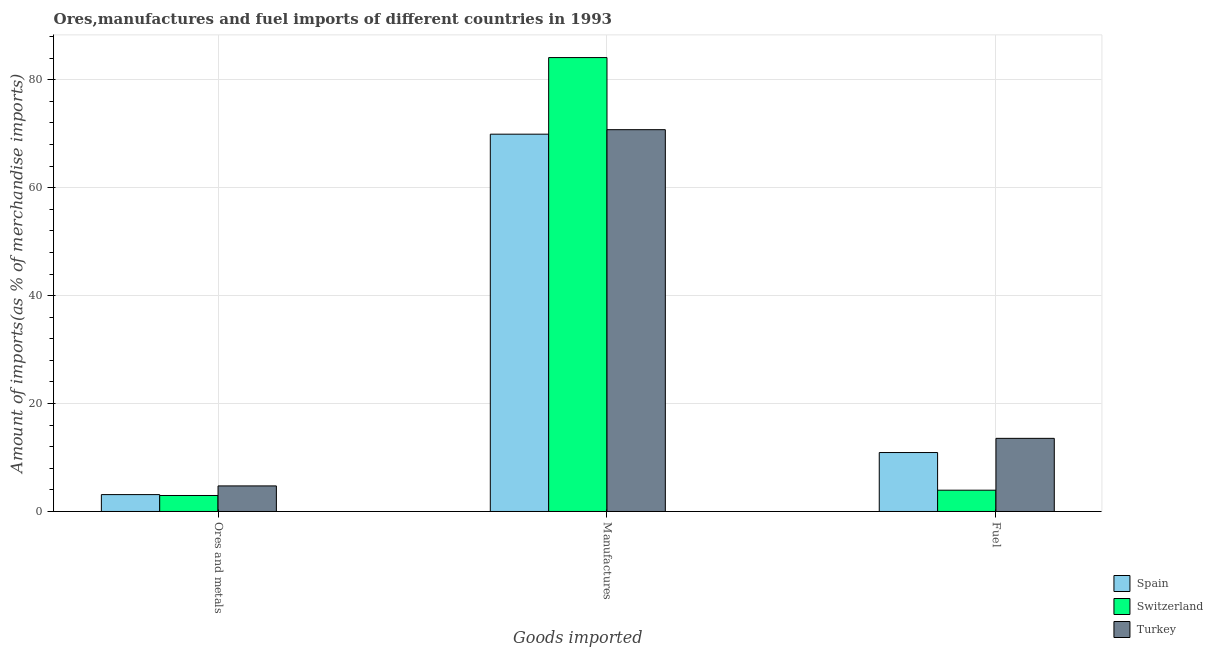Are the number of bars per tick equal to the number of legend labels?
Your answer should be very brief. Yes. Are the number of bars on each tick of the X-axis equal?
Your answer should be very brief. Yes. How many bars are there on the 1st tick from the left?
Offer a terse response. 3. What is the label of the 3rd group of bars from the left?
Your answer should be very brief. Fuel. What is the percentage of fuel imports in Switzerland?
Offer a terse response. 3.95. Across all countries, what is the maximum percentage of manufactures imports?
Provide a succinct answer. 84.12. Across all countries, what is the minimum percentage of ores and metals imports?
Your answer should be very brief. 2.96. In which country was the percentage of manufactures imports maximum?
Your answer should be compact. Switzerland. In which country was the percentage of ores and metals imports minimum?
Your answer should be compact. Switzerland. What is the total percentage of fuel imports in the graph?
Your response must be concise. 28.42. What is the difference between the percentage of ores and metals imports in Turkey and that in Switzerland?
Your answer should be very brief. 1.78. What is the difference between the percentage of manufactures imports in Switzerland and the percentage of fuel imports in Turkey?
Make the answer very short. 70.57. What is the average percentage of fuel imports per country?
Make the answer very short. 9.47. What is the difference between the percentage of manufactures imports and percentage of ores and metals imports in Spain?
Your response must be concise. 66.79. In how many countries, is the percentage of ores and metals imports greater than 20 %?
Keep it short and to the point. 0. What is the ratio of the percentage of fuel imports in Turkey to that in Switzerland?
Offer a terse response. 3.43. Is the percentage of fuel imports in Turkey less than that in Switzerland?
Your answer should be compact. No. What is the difference between the highest and the second highest percentage of fuel imports?
Keep it short and to the point. 2.63. What is the difference between the highest and the lowest percentage of manufactures imports?
Your answer should be very brief. 14.2. In how many countries, is the percentage of ores and metals imports greater than the average percentage of ores and metals imports taken over all countries?
Offer a very short reply. 1. Is the sum of the percentage of fuel imports in Spain and Switzerland greater than the maximum percentage of manufactures imports across all countries?
Offer a very short reply. No. What does the 2nd bar from the left in Manufactures represents?
Provide a short and direct response. Switzerland. What does the 1st bar from the right in Ores and metals represents?
Your answer should be very brief. Turkey. How many bars are there?
Offer a terse response. 9. Are all the bars in the graph horizontal?
Provide a short and direct response. No. How many countries are there in the graph?
Your answer should be compact. 3. What is the difference between two consecutive major ticks on the Y-axis?
Provide a succinct answer. 20. Does the graph contain any zero values?
Ensure brevity in your answer.  No. How many legend labels are there?
Ensure brevity in your answer.  3. What is the title of the graph?
Provide a succinct answer. Ores,manufactures and fuel imports of different countries in 1993. What is the label or title of the X-axis?
Provide a short and direct response. Goods imported. What is the label or title of the Y-axis?
Make the answer very short. Amount of imports(as % of merchandise imports). What is the Amount of imports(as % of merchandise imports) in Spain in Ores and metals?
Provide a short and direct response. 3.13. What is the Amount of imports(as % of merchandise imports) in Switzerland in Ores and metals?
Your answer should be very brief. 2.96. What is the Amount of imports(as % of merchandise imports) in Turkey in Ores and metals?
Ensure brevity in your answer.  4.74. What is the Amount of imports(as % of merchandise imports) of Spain in Manufactures?
Keep it short and to the point. 69.92. What is the Amount of imports(as % of merchandise imports) in Switzerland in Manufactures?
Your response must be concise. 84.12. What is the Amount of imports(as % of merchandise imports) of Turkey in Manufactures?
Your answer should be very brief. 70.76. What is the Amount of imports(as % of merchandise imports) in Spain in Fuel?
Give a very brief answer. 10.92. What is the Amount of imports(as % of merchandise imports) of Switzerland in Fuel?
Make the answer very short. 3.95. What is the Amount of imports(as % of merchandise imports) of Turkey in Fuel?
Ensure brevity in your answer.  13.55. Across all Goods imported, what is the maximum Amount of imports(as % of merchandise imports) in Spain?
Make the answer very short. 69.92. Across all Goods imported, what is the maximum Amount of imports(as % of merchandise imports) of Switzerland?
Make the answer very short. 84.12. Across all Goods imported, what is the maximum Amount of imports(as % of merchandise imports) of Turkey?
Make the answer very short. 70.76. Across all Goods imported, what is the minimum Amount of imports(as % of merchandise imports) of Spain?
Offer a very short reply. 3.13. Across all Goods imported, what is the minimum Amount of imports(as % of merchandise imports) in Switzerland?
Ensure brevity in your answer.  2.96. Across all Goods imported, what is the minimum Amount of imports(as % of merchandise imports) in Turkey?
Give a very brief answer. 4.74. What is the total Amount of imports(as % of merchandise imports) of Spain in the graph?
Your answer should be very brief. 83.98. What is the total Amount of imports(as % of merchandise imports) of Switzerland in the graph?
Make the answer very short. 91.03. What is the total Amount of imports(as % of merchandise imports) of Turkey in the graph?
Ensure brevity in your answer.  89.05. What is the difference between the Amount of imports(as % of merchandise imports) of Spain in Ores and metals and that in Manufactures?
Offer a terse response. -66.79. What is the difference between the Amount of imports(as % of merchandise imports) in Switzerland in Ores and metals and that in Manufactures?
Ensure brevity in your answer.  -81.16. What is the difference between the Amount of imports(as % of merchandise imports) in Turkey in Ores and metals and that in Manufactures?
Your answer should be compact. -66.02. What is the difference between the Amount of imports(as % of merchandise imports) in Spain in Ores and metals and that in Fuel?
Offer a terse response. -7.79. What is the difference between the Amount of imports(as % of merchandise imports) of Switzerland in Ores and metals and that in Fuel?
Your answer should be compact. -0.98. What is the difference between the Amount of imports(as % of merchandise imports) in Turkey in Ores and metals and that in Fuel?
Offer a very short reply. -8.81. What is the difference between the Amount of imports(as % of merchandise imports) in Spain in Manufactures and that in Fuel?
Your answer should be very brief. 59. What is the difference between the Amount of imports(as % of merchandise imports) of Switzerland in Manufactures and that in Fuel?
Give a very brief answer. 80.17. What is the difference between the Amount of imports(as % of merchandise imports) in Turkey in Manufactures and that in Fuel?
Offer a very short reply. 57.21. What is the difference between the Amount of imports(as % of merchandise imports) of Spain in Ores and metals and the Amount of imports(as % of merchandise imports) of Switzerland in Manufactures?
Provide a succinct answer. -80.99. What is the difference between the Amount of imports(as % of merchandise imports) of Spain in Ores and metals and the Amount of imports(as % of merchandise imports) of Turkey in Manufactures?
Give a very brief answer. -67.63. What is the difference between the Amount of imports(as % of merchandise imports) in Switzerland in Ores and metals and the Amount of imports(as % of merchandise imports) in Turkey in Manufactures?
Your answer should be compact. -67.79. What is the difference between the Amount of imports(as % of merchandise imports) in Spain in Ores and metals and the Amount of imports(as % of merchandise imports) in Switzerland in Fuel?
Your answer should be compact. -0.82. What is the difference between the Amount of imports(as % of merchandise imports) of Spain in Ores and metals and the Amount of imports(as % of merchandise imports) of Turkey in Fuel?
Keep it short and to the point. -10.42. What is the difference between the Amount of imports(as % of merchandise imports) in Switzerland in Ores and metals and the Amount of imports(as % of merchandise imports) in Turkey in Fuel?
Provide a succinct answer. -10.59. What is the difference between the Amount of imports(as % of merchandise imports) in Spain in Manufactures and the Amount of imports(as % of merchandise imports) in Switzerland in Fuel?
Keep it short and to the point. 65.98. What is the difference between the Amount of imports(as % of merchandise imports) of Spain in Manufactures and the Amount of imports(as % of merchandise imports) of Turkey in Fuel?
Your response must be concise. 56.37. What is the difference between the Amount of imports(as % of merchandise imports) in Switzerland in Manufactures and the Amount of imports(as % of merchandise imports) in Turkey in Fuel?
Your response must be concise. 70.57. What is the average Amount of imports(as % of merchandise imports) in Spain per Goods imported?
Offer a very short reply. 27.99. What is the average Amount of imports(as % of merchandise imports) of Switzerland per Goods imported?
Your response must be concise. 30.34. What is the average Amount of imports(as % of merchandise imports) of Turkey per Goods imported?
Your response must be concise. 29.68. What is the difference between the Amount of imports(as % of merchandise imports) of Spain and Amount of imports(as % of merchandise imports) of Switzerland in Ores and metals?
Keep it short and to the point. 0.17. What is the difference between the Amount of imports(as % of merchandise imports) of Spain and Amount of imports(as % of merchandise imports) of Turkey in Ores and metals?
Provide a succinct answer. -1.61. What is the difference between the Amount of imports(as % of merchandise imports) of Switzerland and Amount of imports(as % of merchandise imports) of Turkey in Ores and metals?
Give a very brief answer. -1.78. What is the difference between the Amount of imports(as % of merchandise imports) in Spain and Amount of imports(as % of merchandise imports) in Switzerland in Manufactures?
Your response must be concise. -14.2. What is the difference between the Amount of imports(as % of merchandise imports) in Spain and Amount of imports(as % of merchandise imports) in Turkey in Manufactures?
Make the answer very short. -0.83. What is the difference between the Amount of imports(as % of merchandise imports) of Switzerland and Amount of imports(as % of merchandise imports) of Turkey in Manufactures?
Your answer should be very brief. 13.36. What is the difference between the Amount of imports(as % of merchandise imports) in Spain and Amount of imports(as % of merchandise imports) in Switzerland in Fuel?
Give a very brief answer. 6.98. What is the difference between the Amount of imports(as % of merchandise imports) of Spain and Amount of imports(as % of merchandise imports) of Turkey in Fuel?
Your answer should be compact. -2.63. What is the difference between the Amount of imports(as % of merchandise imports) of Switzerland and Amount of imports(as % of merchandise imports) of Turkey in Fuel?
Ensure brevity in your answer.  -9.61. What is the ratio of the Amount of imports(as % of merchandise imports) of Spain in Ores and metals to that in Manufactures?
Give a very brief answer. 0.04. What is the ratio of the Amount of imports(as % of merchandise imports) of Switzerland in Ores and metals to that in Manufactures?
Make the answer very short. 0.04. What is the ratio of the Amount of imports(as % of merchandise imports) of Turkey in Ores and metals to that in Manufactures?
Your answer should be very brief. 0.07. What is the ratio of the Amount of imports(as % of merchandise imports) in Spain in Ores and metals to that in Fuel?
Ensure brevity in your answer.  0.29. What is the ratio of the Amount of imports(as % of merchandise imports) of Switzerland in Ores and metals to that in Fuel?
Your response must be concise. 0.75. What is the ratio of the Amount of imports(as % of merchandise imports) of Turkey in Ores and metals to that in Fuel?
Give a very brief answer. 0.35. What is the ratio of the Amount of imports(as % of merchandise imports) of Spain in Manufactures to that in Fuel?
Ensure brevity in your answer.  6.4. What is the ratio of the Amount of imports(as % of merchandise imports) in Switzerland in Manufactures to that in Fuel?
Keep it short and to the point. 21.32. What is the ratio of the Amount of imports(as % of merchandise imports) in Turkey in Manufactures to that in Fuel?
Provide a short and direct response. 5.22. What is the difference between the highest and the second highest Amount of imports(as % of merchandise imports) in Spain?
Provide a short and direct response. 59. What is the difference between the highest and the second highest Amount of imports(as % of merchandise imports) in Switzerland?
Make the answer very short. 80.17. What is the difference between the highest and the second highest Amount of imports(as % of merchandise imports) in Turkey?
Offer a very short reply. 57.21. What is the difference between the highest and the lowest Amount of imports(as % of merchandise imports) in Spain?
Ensure brevity in your answer.  66.79. What is the difference between the highest and the lowest Amount of imports(as % of merchandise imports) in Switzerland?
Give a very brief answer. 81.16. What is the difference between the highest and the lowest Amount of imports(as % of merchandise imports) of Turkey?
Ensure brevity in your answer.  66.02. 